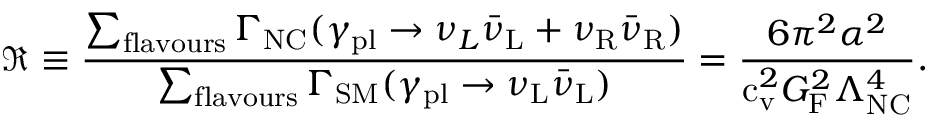Convert formula to latex. <formula><loc_0><loc_0><loc_500><loc_500>\Re \equiv \frac { \sum _ { f l a v o u r s } \Gamma _ { N C } ( \gamma _ { p l } \to { \nu _ { L } } { \bar { \nu } } _ { L } + { \nu _ { R } } { \bar { \nu } } _ { R } ) } { \sum _ { f l a v o u r s } \Gamma _ { S M } ( \gamma _ { p l } \to { \nu _ { L } } { \bar { \nu } } _ { L } ) } = \frac { 6 \pi ^ { 2 } \alpha ^ { 2 } } { c _ { v } ^ { 2 } G _ { F } ^ { 2 } \Lambda _ { N C } ^ { 4 } } .</formula> 